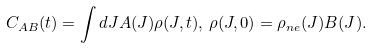<formula> <loc_0><loc_0><loc_500><loc_500>C _ { A B } ( t ) = \int d J A ( J ) \rho ( J , t ) , \, \rho ( J , 0 ) = \rho _ { n e } ( J ) B ( J ) .</formula> 